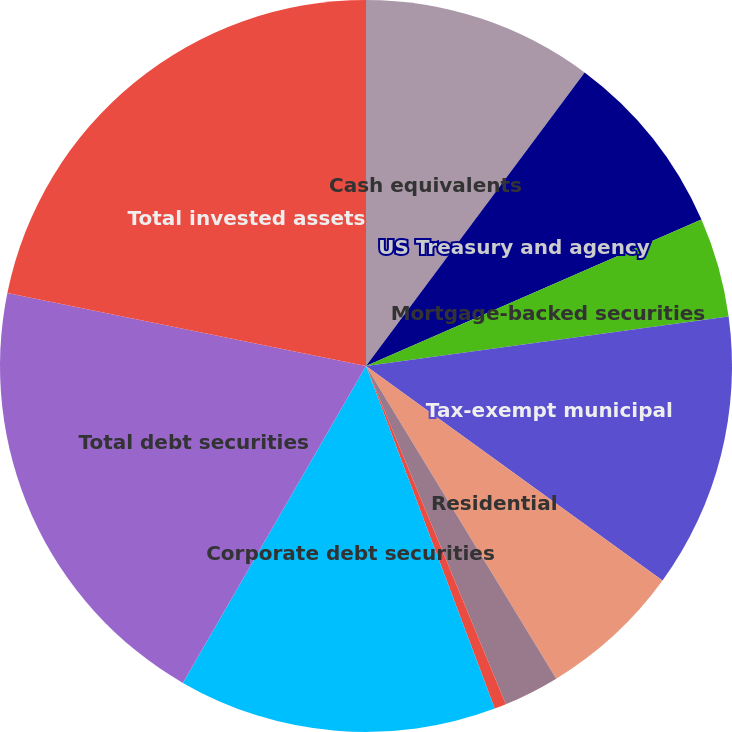Convert chart. <chart><loc_0><loc_0><loc_500><loc_500><pie_chart><fcel>Cash equivalents<fcel>US Treasury and agency<fcel>Mortgage-backed securities<fcel>Tax-exempt municipal<fcel>Residential<fcel>Commercial<fcel>Asset-backed securities<fcel>Corporate debt securities<fcel>Total debt securities<fcel>Total invested assets<nl><fcel>10.19%<fcel>8.26%<fcel>4.39%<fcel>12.13%<fcel>6.33%<fcel>2.46%<fcel>0.52%<fcel>14.06%<fcel>19.86%<fcel>21.8%<nl></chart> 